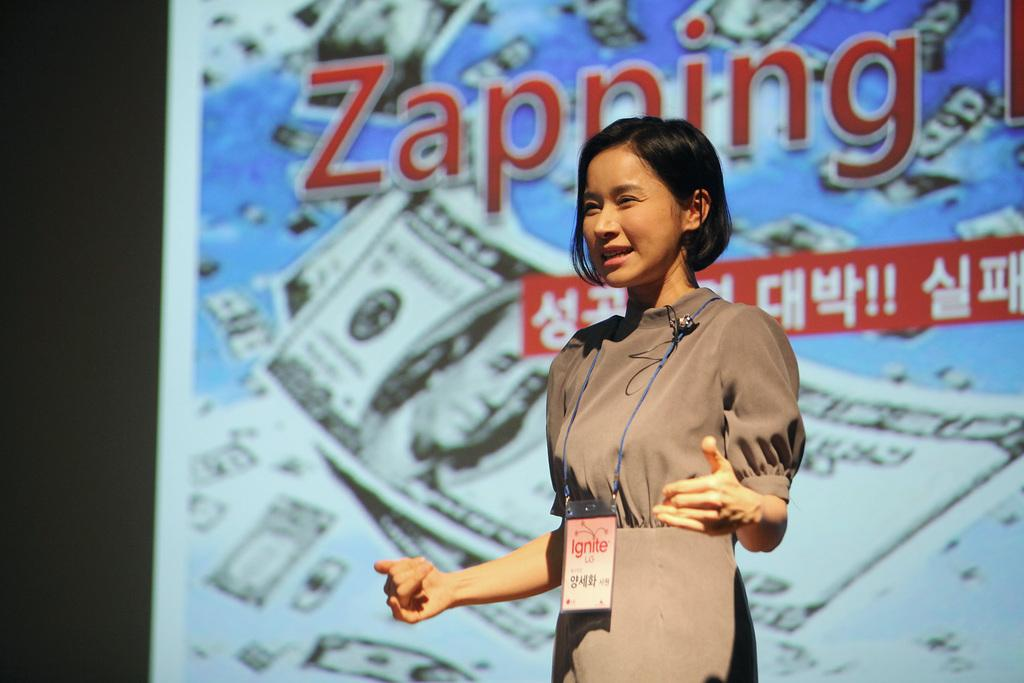Who is the main subject in the image? There is a lady in the center of the image. What can be seen in the background of the image? There is a poster in the background area. What advice does the lady give to the person on the island in the image? There is no person on an island present in the image, and the lady does not appear to be giving any advice. 